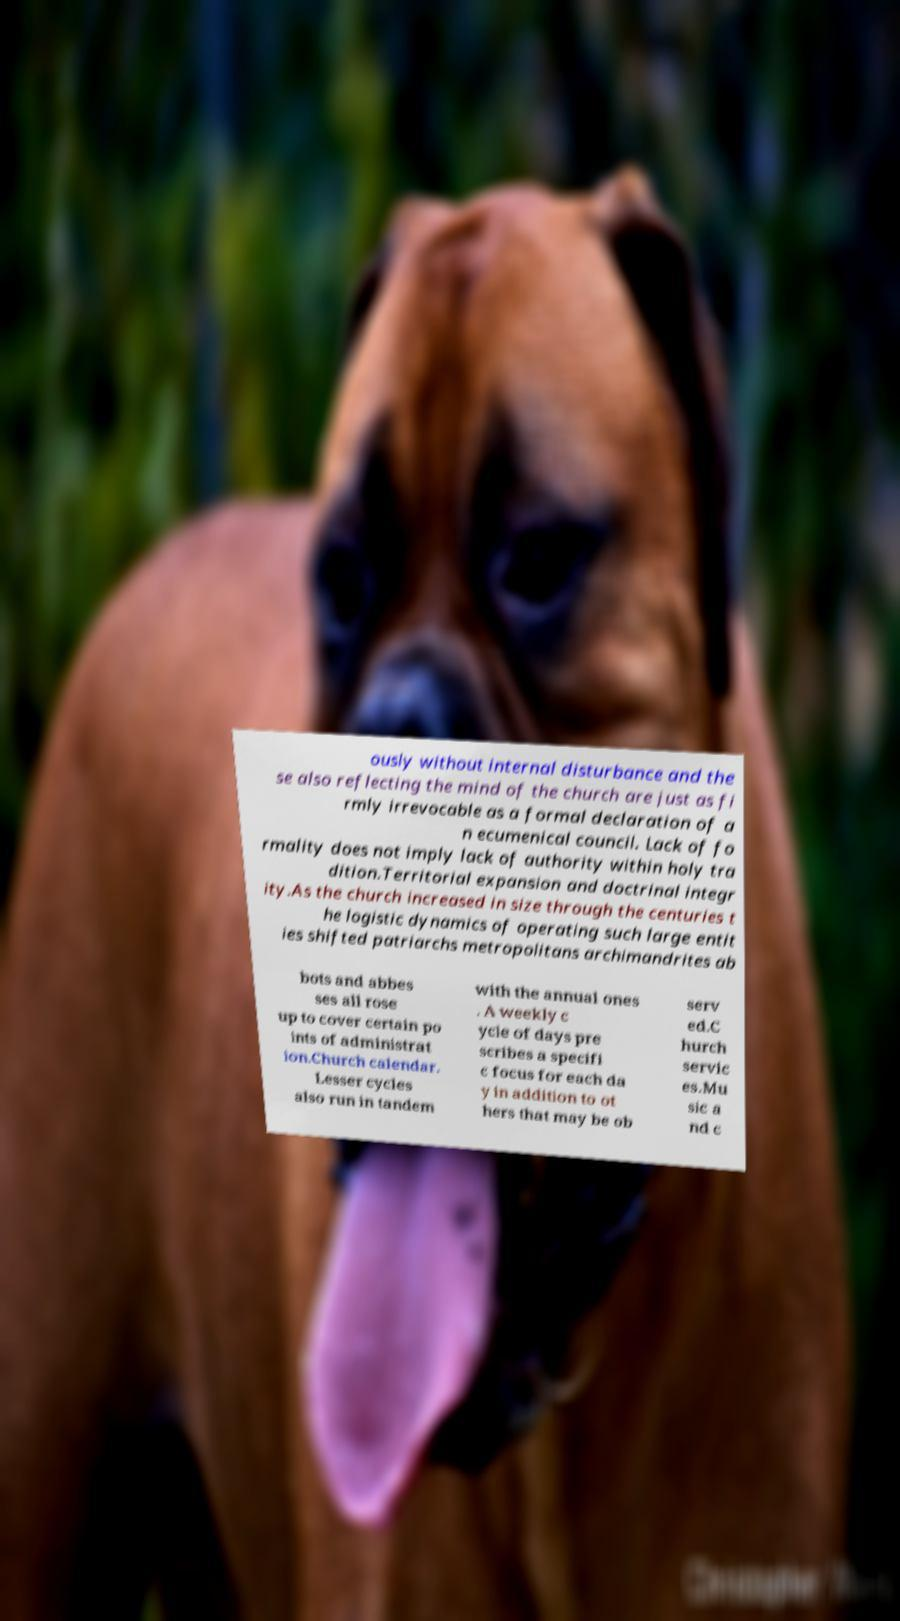There's text embedded in this image that I need extracted. Can you transcribe it verbatim? ously without internal disturbance and the se also reflecting the mind of the church are just as fi rmly irrevocable as a formal declaration of a n ecumenical council. Lack of fo rmality does not imply lack of authority within holy tra dition.Territorial expansion and doctrinal integr ity.As the church increased in size through the centuries t he logistic dynamics of operating such large entit ies shifted patriarchs metropolitans archimandrites ab bots and abbes ses all rose up to cover certain po ints of administrat ion.Church calendar. Lesser cycles also run in tandem with the annual ones . A weekly c ycle of days pre scribes a specifi c focus for each da y in addition to ot hers that may be ob serv ed.C hurch servic es.Mu sic a nd c 